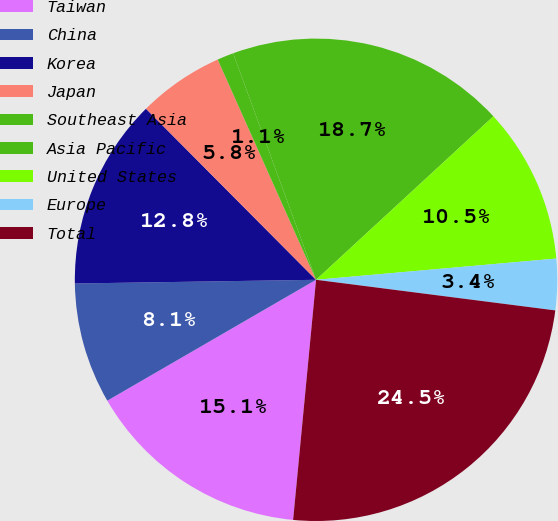<chart> <loc_0><loc_0><loc_500><loc_500><pie_chart><fcel>Taiwan<fcel>China<fcel>Korea<fcel>Japan<fcel>Southeast Asia<fcel>Asia Pacific<fcel>United States<fcel>Europe<fcel>Total<nl><fcel>15.13%<fcel>8.11%<fcel>12.79%<fcel>5.77%<fcel>1.1%<fcel>18.73%<fcel>10.45%<fcel>3.43%<fcel>24.49%<nl></chart> 